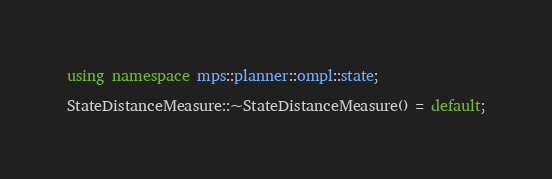<code> <loc_0><loc_0><loc_500><loc_500><_C++_>
using namespace mps::planner::ompl::state;

StateDistanceMeasure::~StateDistanceMeasure() = default;

</code> 